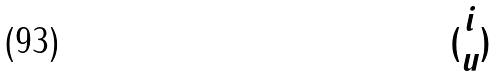Convert formula to latex. <formula><loc_0><loc_0><loc_500><loc_500>( \begin{matrix} i \\ u \end{matrix} )</formula> 